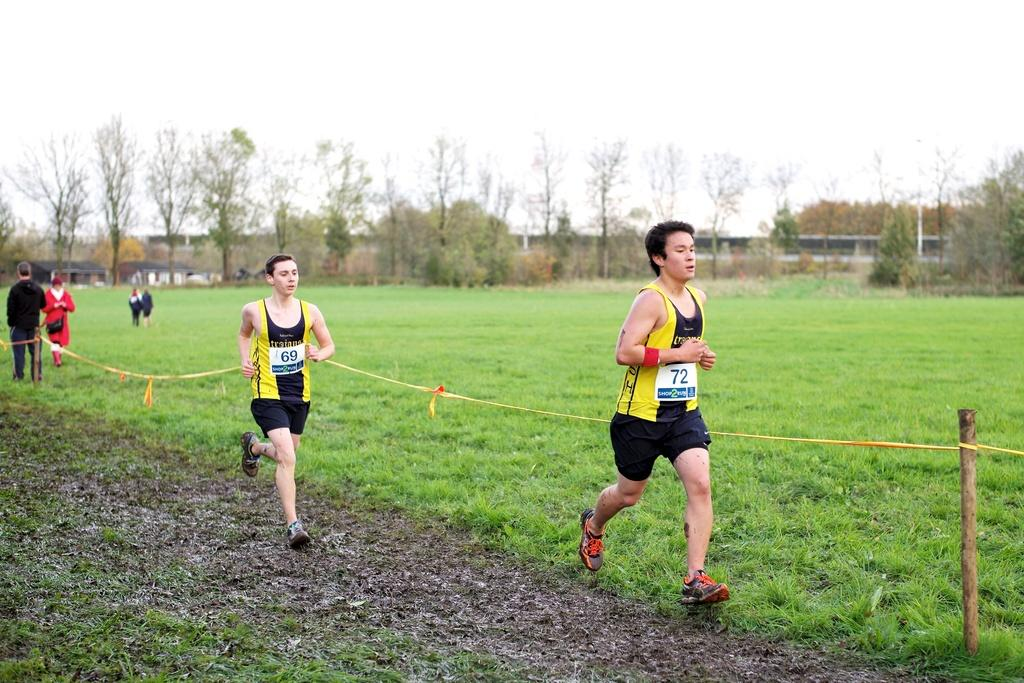<image>
Offer a succinct explanation of the picture presented. Two men running outside and one has the number 72 on his shirt. 